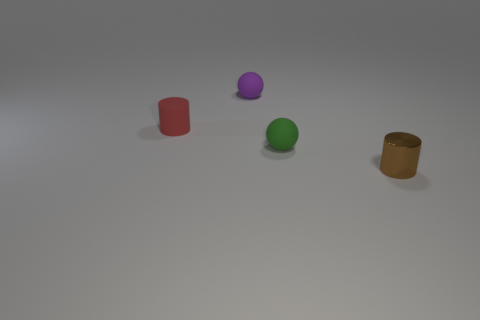Is there anything about the objects' arrangement that stands out? The objects are arranged in a seemingly random configuration, spaced apart from one another on the surface. This spread-out arrangement could be to showcase the individuality and colors of each object without overlap, possibly for an illustrative purpose such as a rendering test. 